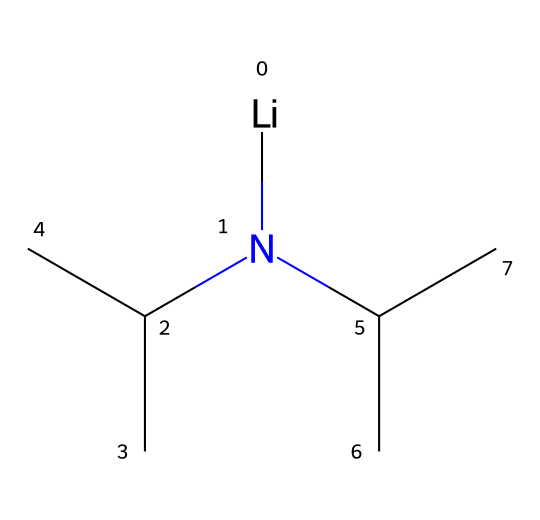What is the chemical name of the compound represented by the SMILES? The SMILES representation indicates the presence of lithium, nitrogen, and isopropyl groups, leading to the name lithium diisopropylamide.
Answer: lithium diisopropylamide How many carbon atoms are in this molecule? By analyzing the structure, there are two isopropyl groups, each containing three carbon atoms, contributing a total of six carbon atoms, plus one carbon from the nitrogen attachment.
Answer: seven What type of bonding is predominantly present in lithium diisopropylamide? The structure shows predominantly ionic bonding between lithium and nitrogen due to the strong basicity of the amide, along with covalent bonds within the isopropyl groups.
Answer: ionic and covalent What is the role of lithium in this superbase? Lithium acts to stabilize the negative charge on the nitrogen atom, enhancing the basicity of the compound and enabling it to act as a strong non-nucleophilic base.
Answer: stabilization How does the steric hindrance in lithium diisopropylamide affect its reactivity? The bulky isopropyl groups create significant steric hindrance, which shields the nitrogen atom, preventing nucleophilic attack while allowing it to act as a strong base.
Answer: inhibits nucleophilic attack Which functional group is primarily responsible for the base properties of the compound? The amide functional group (-N) is the main contributor to the basic properties because it can easily donate a lone pair to deprotonate other compounds.
Answer: amide functional group 